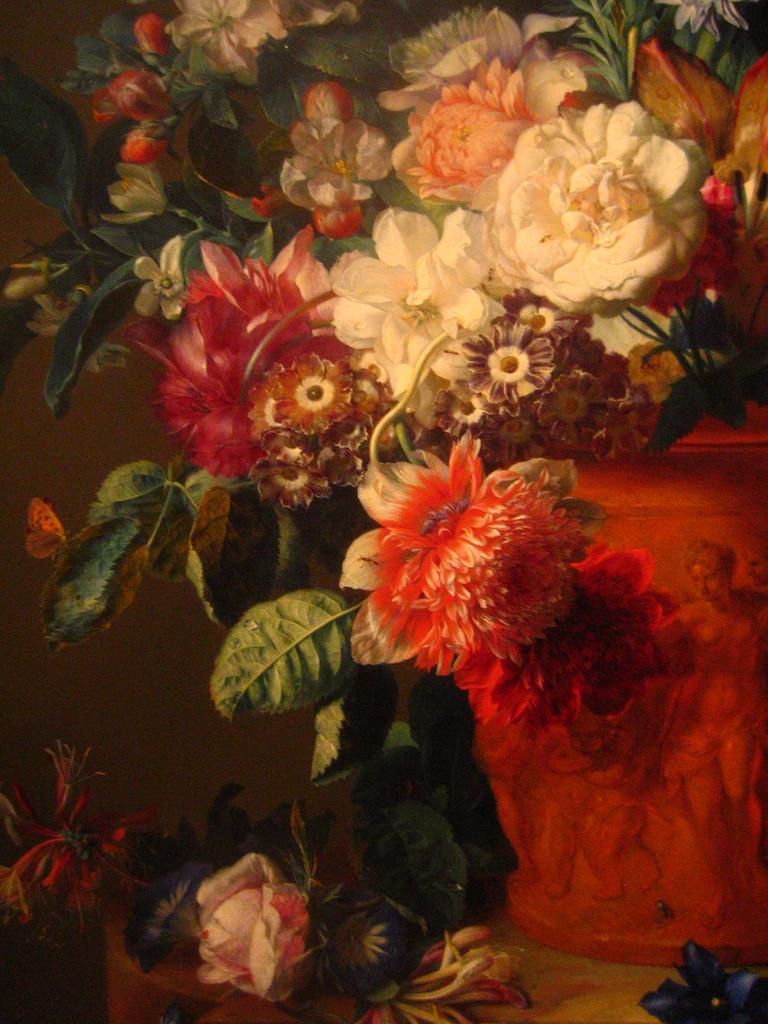Could you give a brief overview of what you see in this image? In the image we can see there is a poster and there is a painting of flowers on the plant. The plant is kept in the vase and there is a painting of people standing on the vase. The vase is kept on the table. 